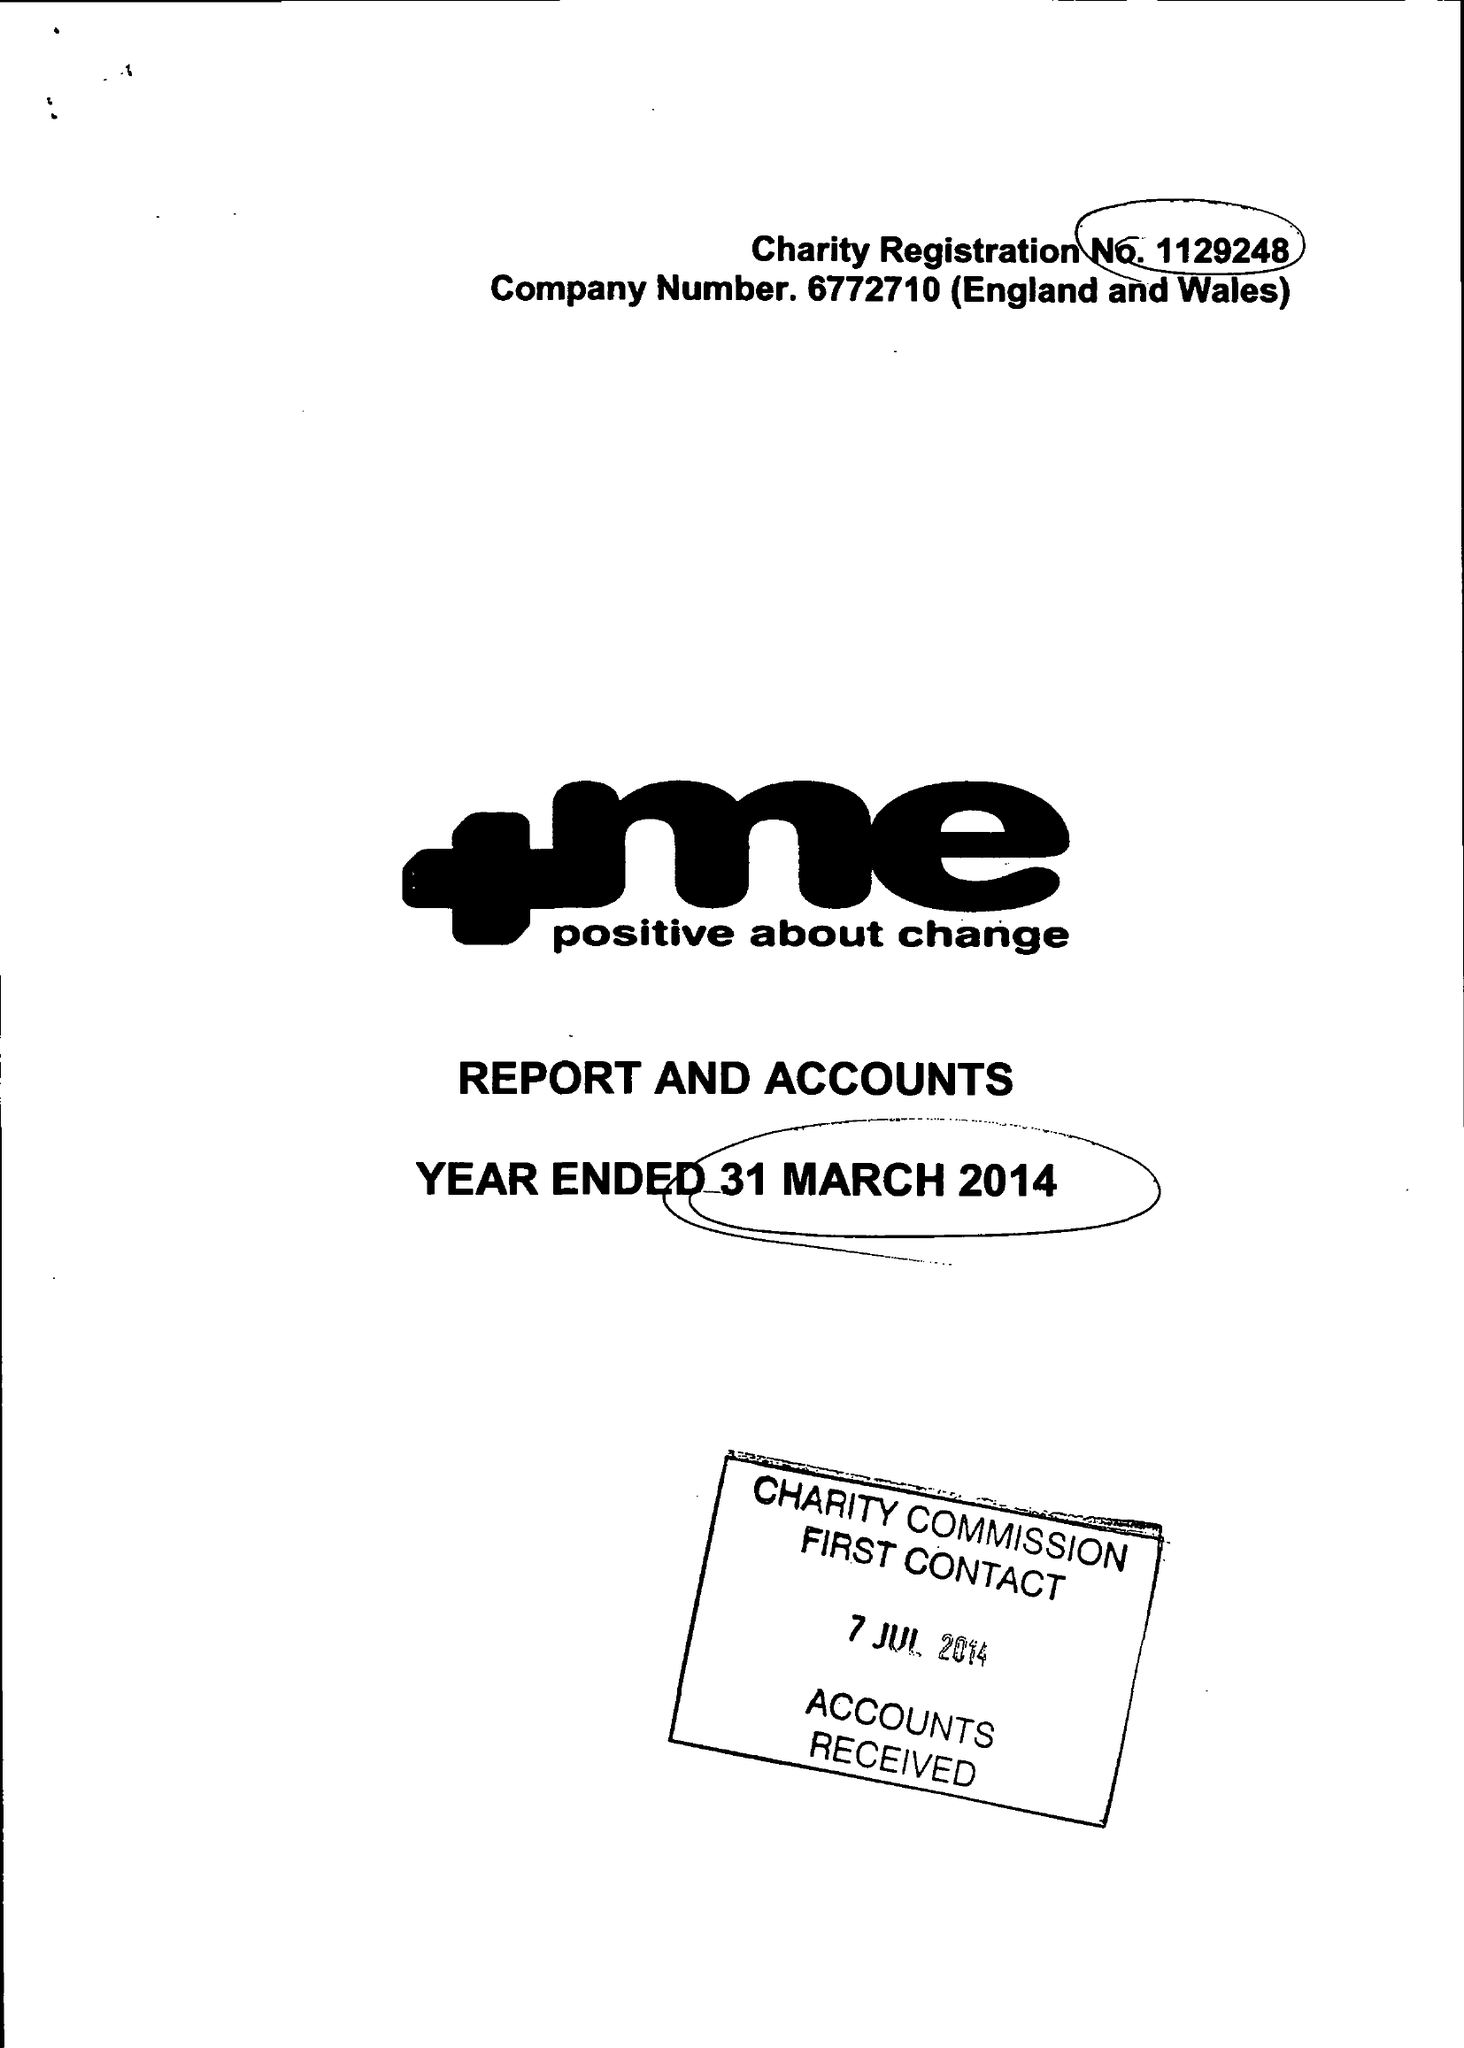What is the value for the report_date?
Answer the question using a single word or phrase. 2014-03-31 